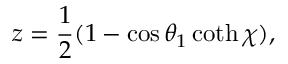Convert formula to latex. <formula><loc_0><loc_0><loc_500><loc_500>z = \frac { 1 } { 2 } ( 1 - \cos \theta _ { 1 } \coth \chi ) ,</formula> 